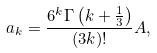<formula> <loc_0><loc_0><loc_500><loc_500>a _ { k } = \frac { 6 ^ { k } \Gamma \left ( k + \frac { 1 } { 3 } \right ) } { ( 3 k ) ! } A ,</formula> 